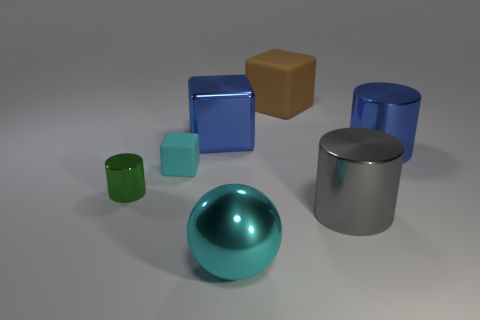Add 2 tiny cyan metallic things. How many objects exist? 9 Subtract all balls. How many objects are left? 6 Subtract all tiny brown cylinders. Subtract all big blue shiny cubes. How many objects are left? 6 Add 3 green things. How many green things are left? 4 Add 3 big cylinders. How many big cylinders exist? 5 Subtract 0 gray cubes. How many objects are left? 7 